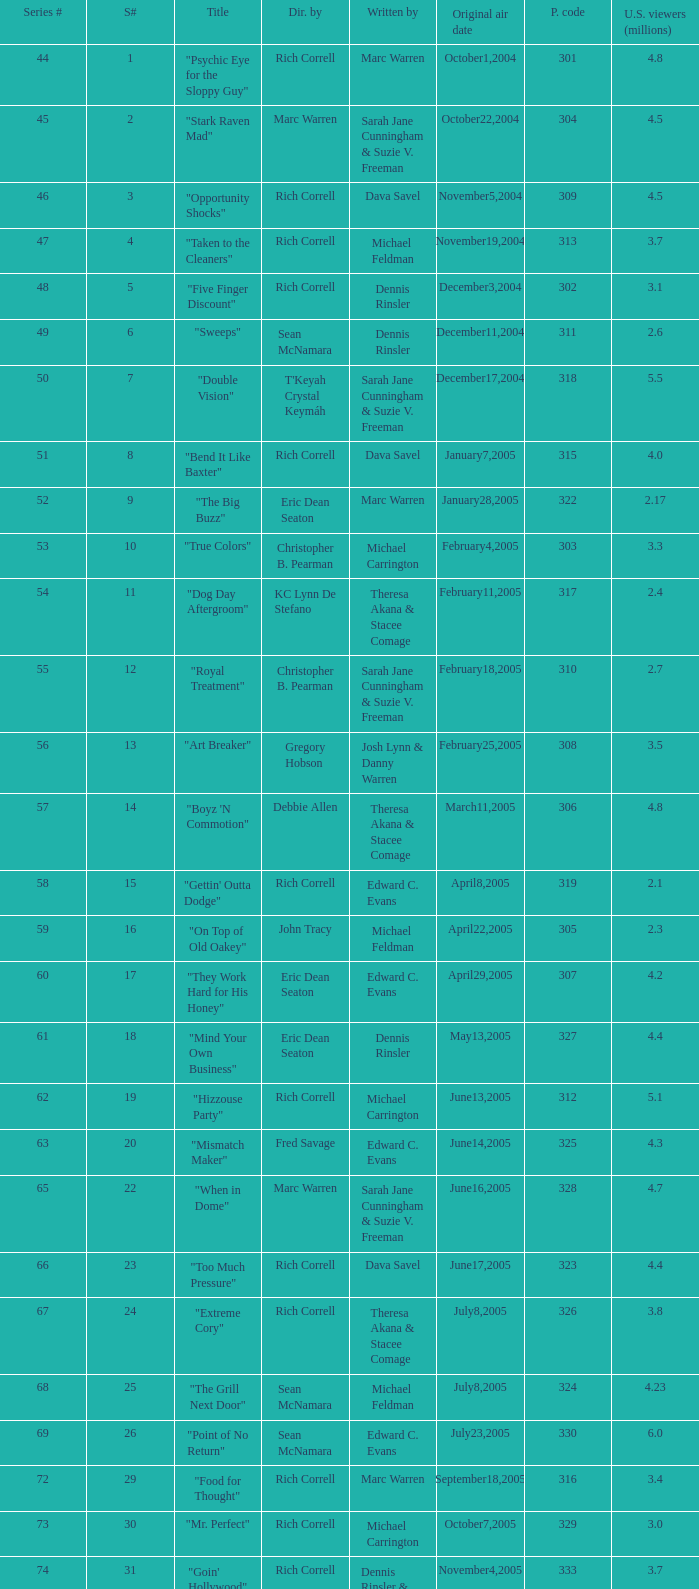What number episode in the season had a production code of 334? 32.0. 